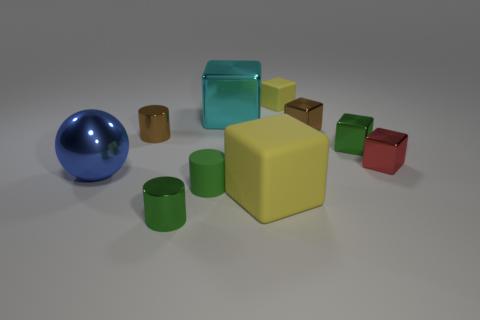Subtract 2 blocks. How many blocks are left? 4 Subtract all tiny brown cubes. How many cubes are left? 5 Subtract all yellow blocks. How many blocks are left? 4 Subtract all cyan blocks. Subtract all yellow cylinders. How many blocks are left? 5 Subtract all cylinders. How many objects are left? 7 Subtract 1 cyan blocks. How many objects are left? 9 Subtract all large green rubber objects. Subtract all small yellow blocks. How many objects are left? 9 Add 2 matte objects. How many matte objects are left? 5 Add 6 big brown rubber blocks. How many big brown rubber blocks exist? 6 